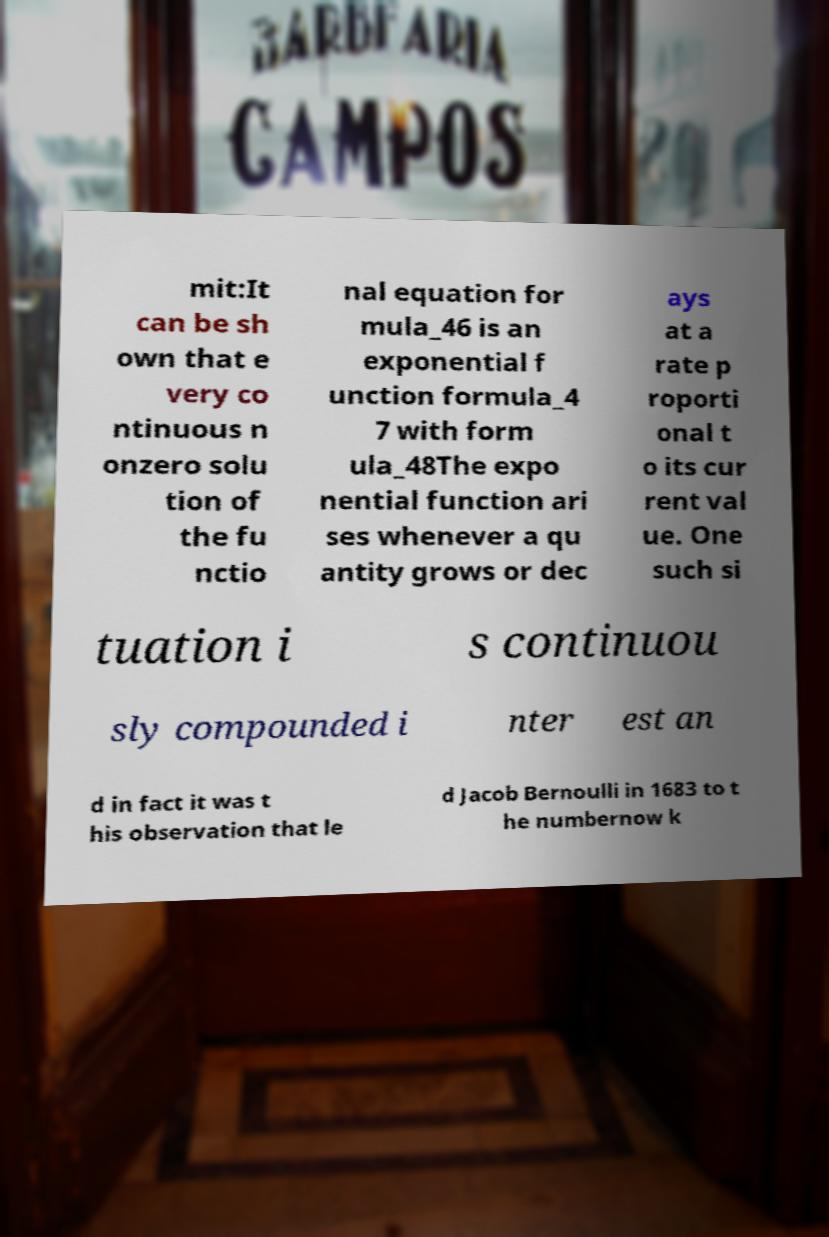What messages or text are displayed in this image? I need them in a readable, typed format. mit:It can be sh own that e very co ntinuous n onzero solu tion of the fu nctio nal equation for mula_46 is an exponential f unction formula_4 7 with form ula_48The expo nential function ari ses whenever a qu antity grows or dec ays at a rate p roporti onal t o its cur rent val ue. One such si tuation i s continuou sly compounded i nter est an d in fact it was t his observation that le d Jacob Bernoulli in 1683 to t he numbernow k 